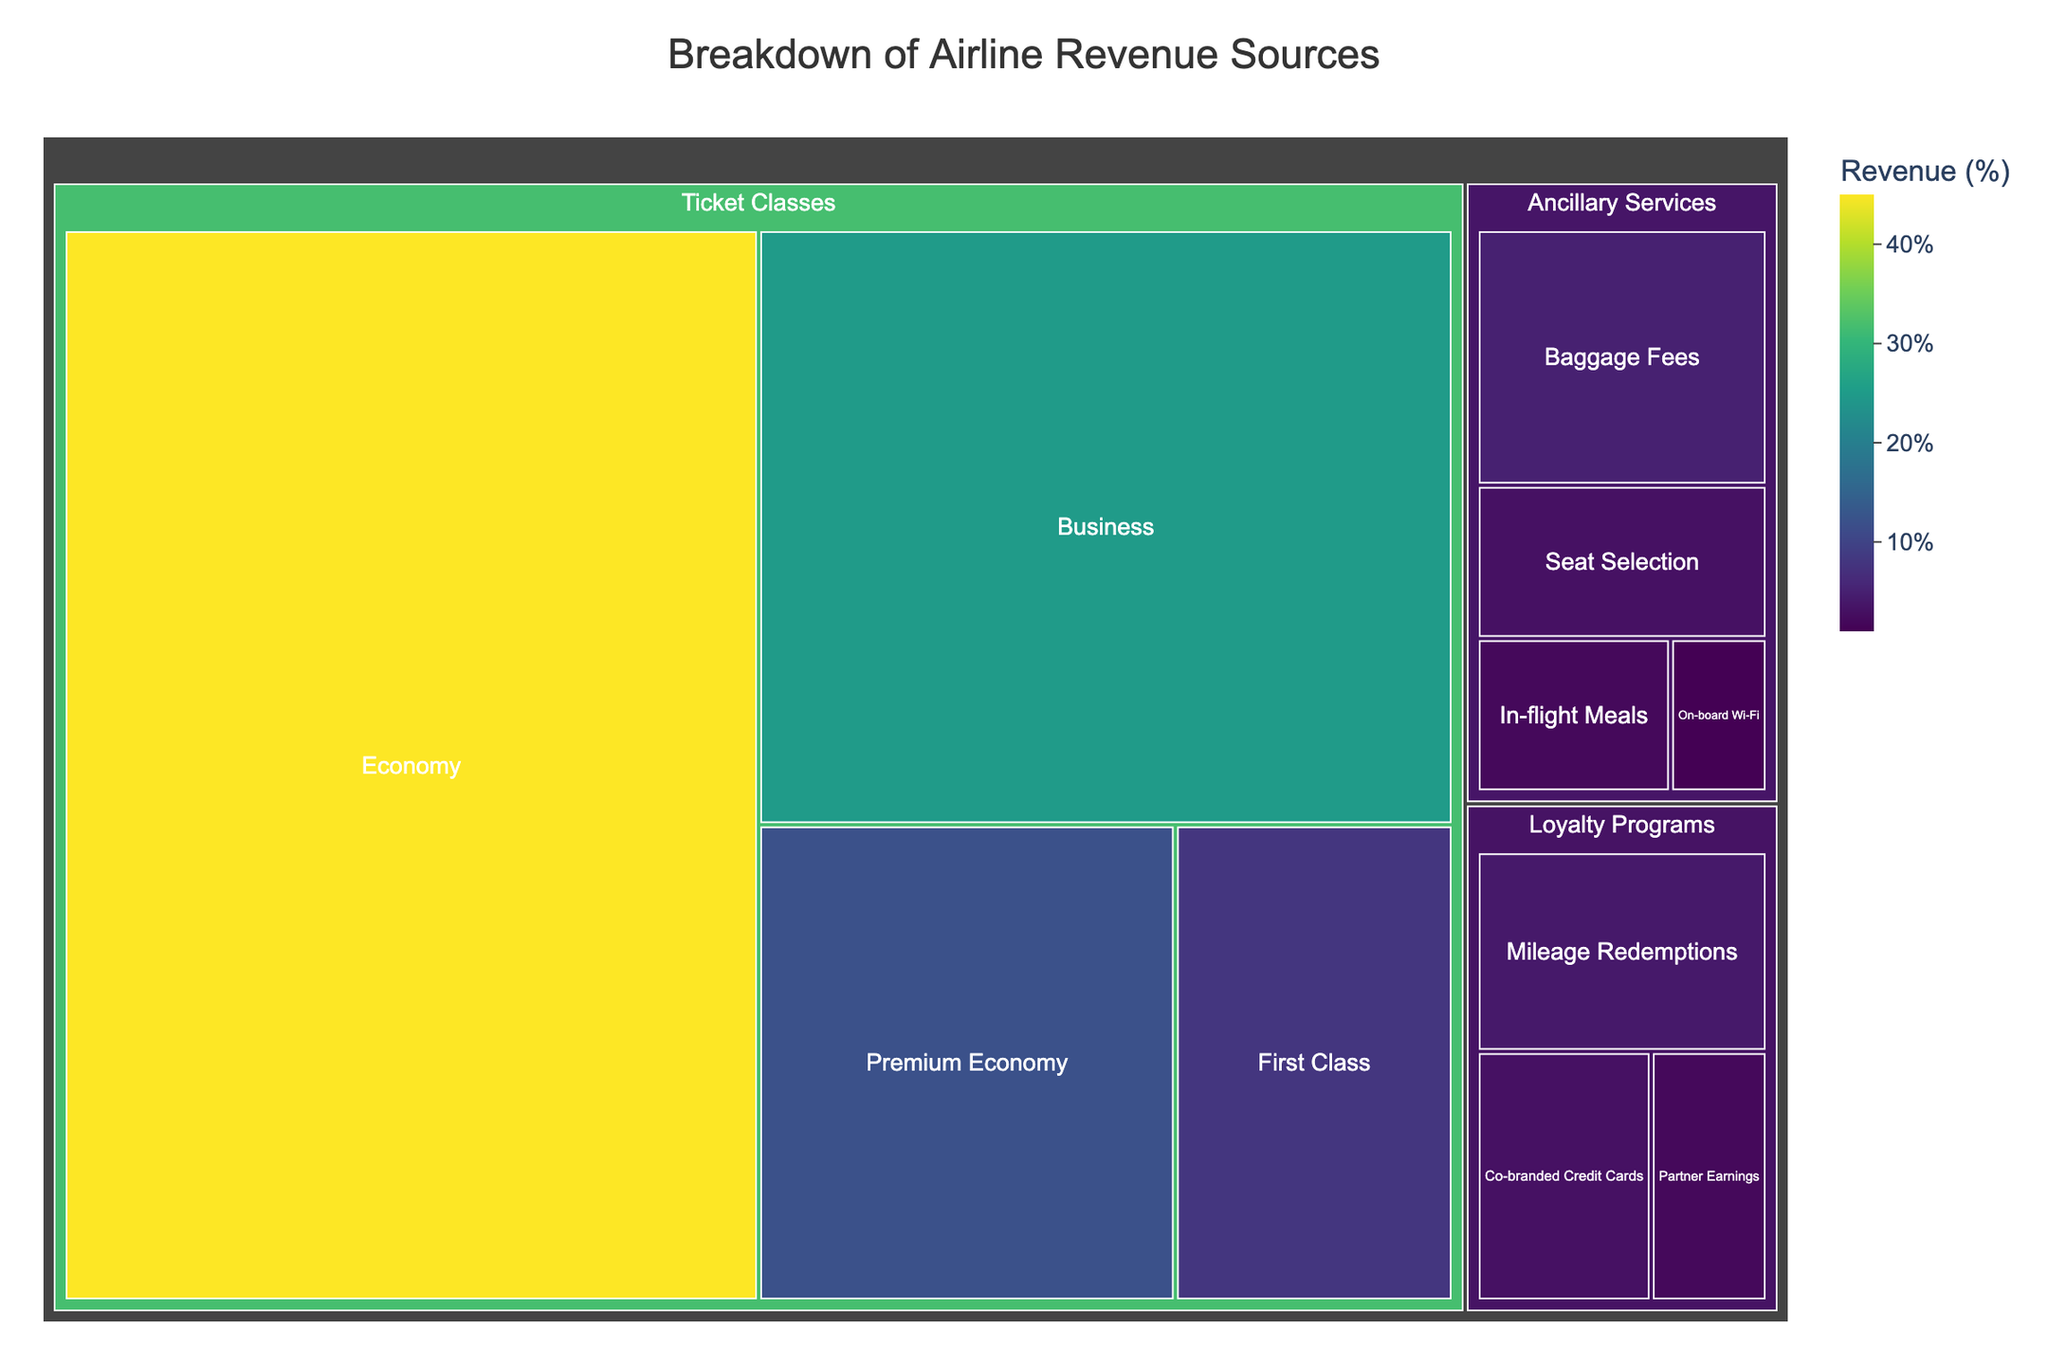What is the title of the treemap? The title is displayed at the top of the treemap. It is usually clearly marked and easy to read.
Answer: Breakdown of Airline Revenue Sources Which subcategory in Ticket Classes contributes the most to the revenue? By looking at the size of the colored blocks in the treemap, identify the largest block under Ticket Classes.
Answer: Economy How much revenue does First Class generate? Locate the section for First Class in the Ticket Classes category and read the revenue percentage listed.
Answer: 8% What is the total revenue contribution from Ancillary Services? Sum the revenue percentages for all the subcategories under Ancillary Services. Add 5% (Baggage Fees), 3% (Seat Selection), 2% (In-flight Meals), and 1% (On-board Wi-Fi).
Answer: 11% How do the combined revenues of Business and Premium Economy compare to Economy alone? First, sum the revenue percentages of Business (25%) and Premium Economy (12%). Then, compare this total (37%) to the revenue percentage of Economy (45%).
Answer: Economy is higher by 8% Which category has the least diverse revenue sources based on the number of subcategories? Count the number of subcategories under each major category (Ticket Classes, Ancillary Services, and Loyalty Programs). The category with the fewest subcategories has the least diverse revenue sources.
Answer: Loyalty Programs How much more revenue does Mileage Redemptions generate compared to On-board Wi-Fi? Find the revenue percentages for Mileage Redemptions (4%) and On-board Wi-Fi (1%), then calculate the difference by subtraction.
Answer: 3% What is the revenue contribution of the largest loyalty program subcategory? Identify the largest block within the Loyalty Programs section and read the revenue percentage listed.
Answer: Mileage Redemptions, 4% Which has higher revenue, Baggage Fees or Co-branded Credit Cards? Compare the revenue percentages for Baggage Fees (5%) and Co-branded Credit Cards (3%).
Answer: Baggage Fees How much revenue do the Loyalty Programs generate in total? Add up the revenue percentages for all subcategories under Loyalty Programs: Mileage Redemptions (4%), Co-branded Credit Cards (3%), and Partner Earnings (2%).
Answer: 9% 